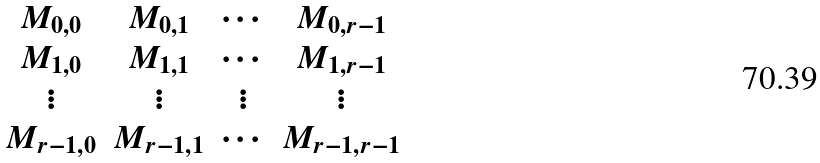Convert formula to latex. <formula><loc_0><loc_0><loc_500><loc_500>\begin{matrix} M _ { 0 , 0 } & M _ { 0 , 1 } & \cdots & M _ { 0 , r - 1 } \\ M _ { 1 , 0 } & M _ { 1 , 1 } & \cdots & M _ { 1 , r - 1 } \\ \vdots & \vdots & \vdots & \vdots \\ M _ { r - 1 , 0 } & M _ { r - 1 , 1 } & \cdots & M _ { r - 1 , r - 1 } \\ \end{matrix}</formula> 